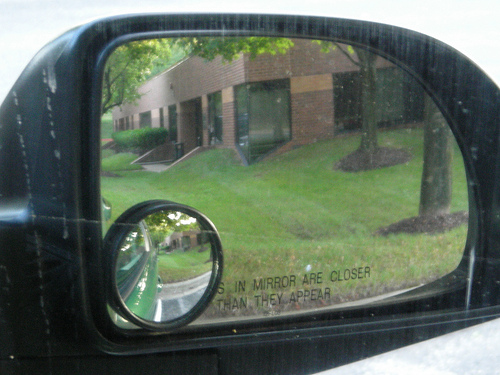<image>
Is there a building in front of the grass? No. The building is not in front of the grass. The spatial positioning shows a different relationship between these objects. 